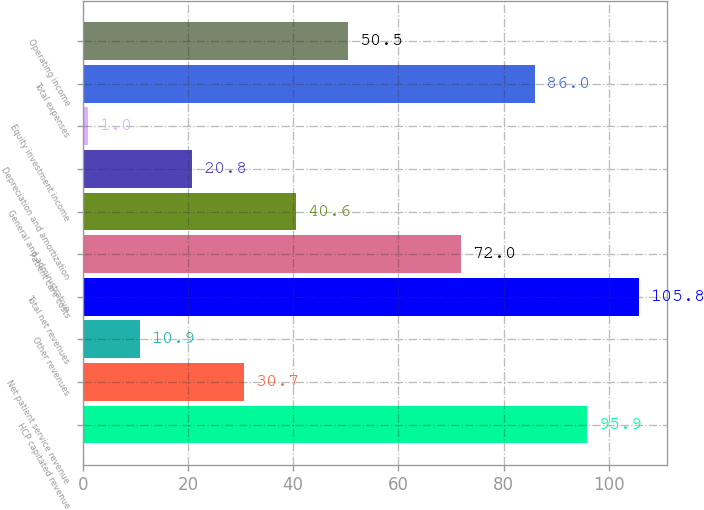Convert chart. <chart><loc_0><loc_0><loc_500><loc_500><bar_chart><fcel>HCP capitated revenue<fcel>Net patient service revenue<fcel>Other revenues<fcel>Total net revenues<fcel>Patient care costs<fcel>General and administrative<fcel>Depreciation and amortization<fcel>Equity investment income<fcel>Total expenses<fcel>Operating income<nl><fcel>95.9<fcel>30.7<fcel>10.9<fcel>105.8<fcel>72<fcel>40.6<fcel>20.8<fcel>1<fcel>86<fcel>50.5<nl></chart> 